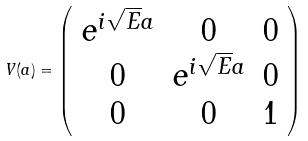Convert formula to latex. <formula><loc_0><loc_0><loc_500><loc_500>V ( a ) = \left ( \begin{array} { c c c } e ^ { i \sqrt { E } a } & 0 & 0 \\ 0 & e ^ { i \sqrt { E } a } & 0 \\ 0 & 0 & 1 \end{array} \right )</formula> 